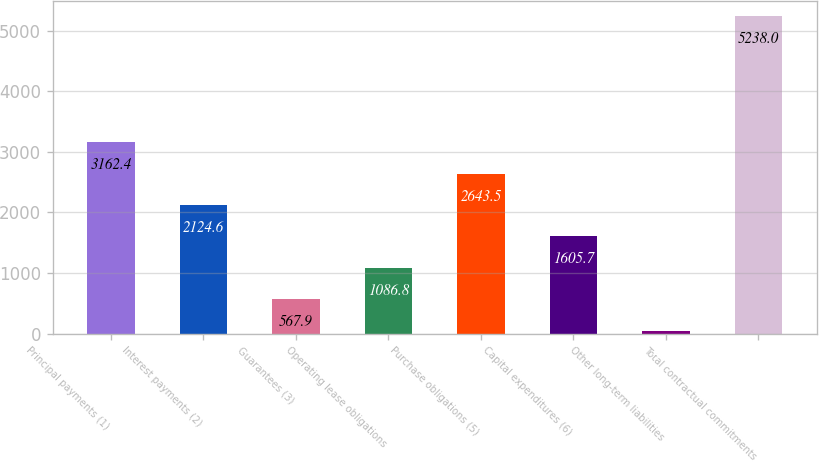Convert chart to OTSL. <chart><loc_0><loc_0><loc_500><loc_500><bar_chart><fcel>Principal payments (1)<fcel>Interest payments (2)<fcel>Guarantees (3)<fcel>Operating lease obligations<fcel>Purchase obligations (5)<fcel>Capital expenditures (6)<fcel>Other long-term liabilities<fcel>Total contractual commitments<nl><fcel>3162.4<fcel>2124.6<fcel>567.9<fcel>1086.8<fcel>2643.5<fcel>1605.7<fcel>49<fcel>5238<nl></chart> 